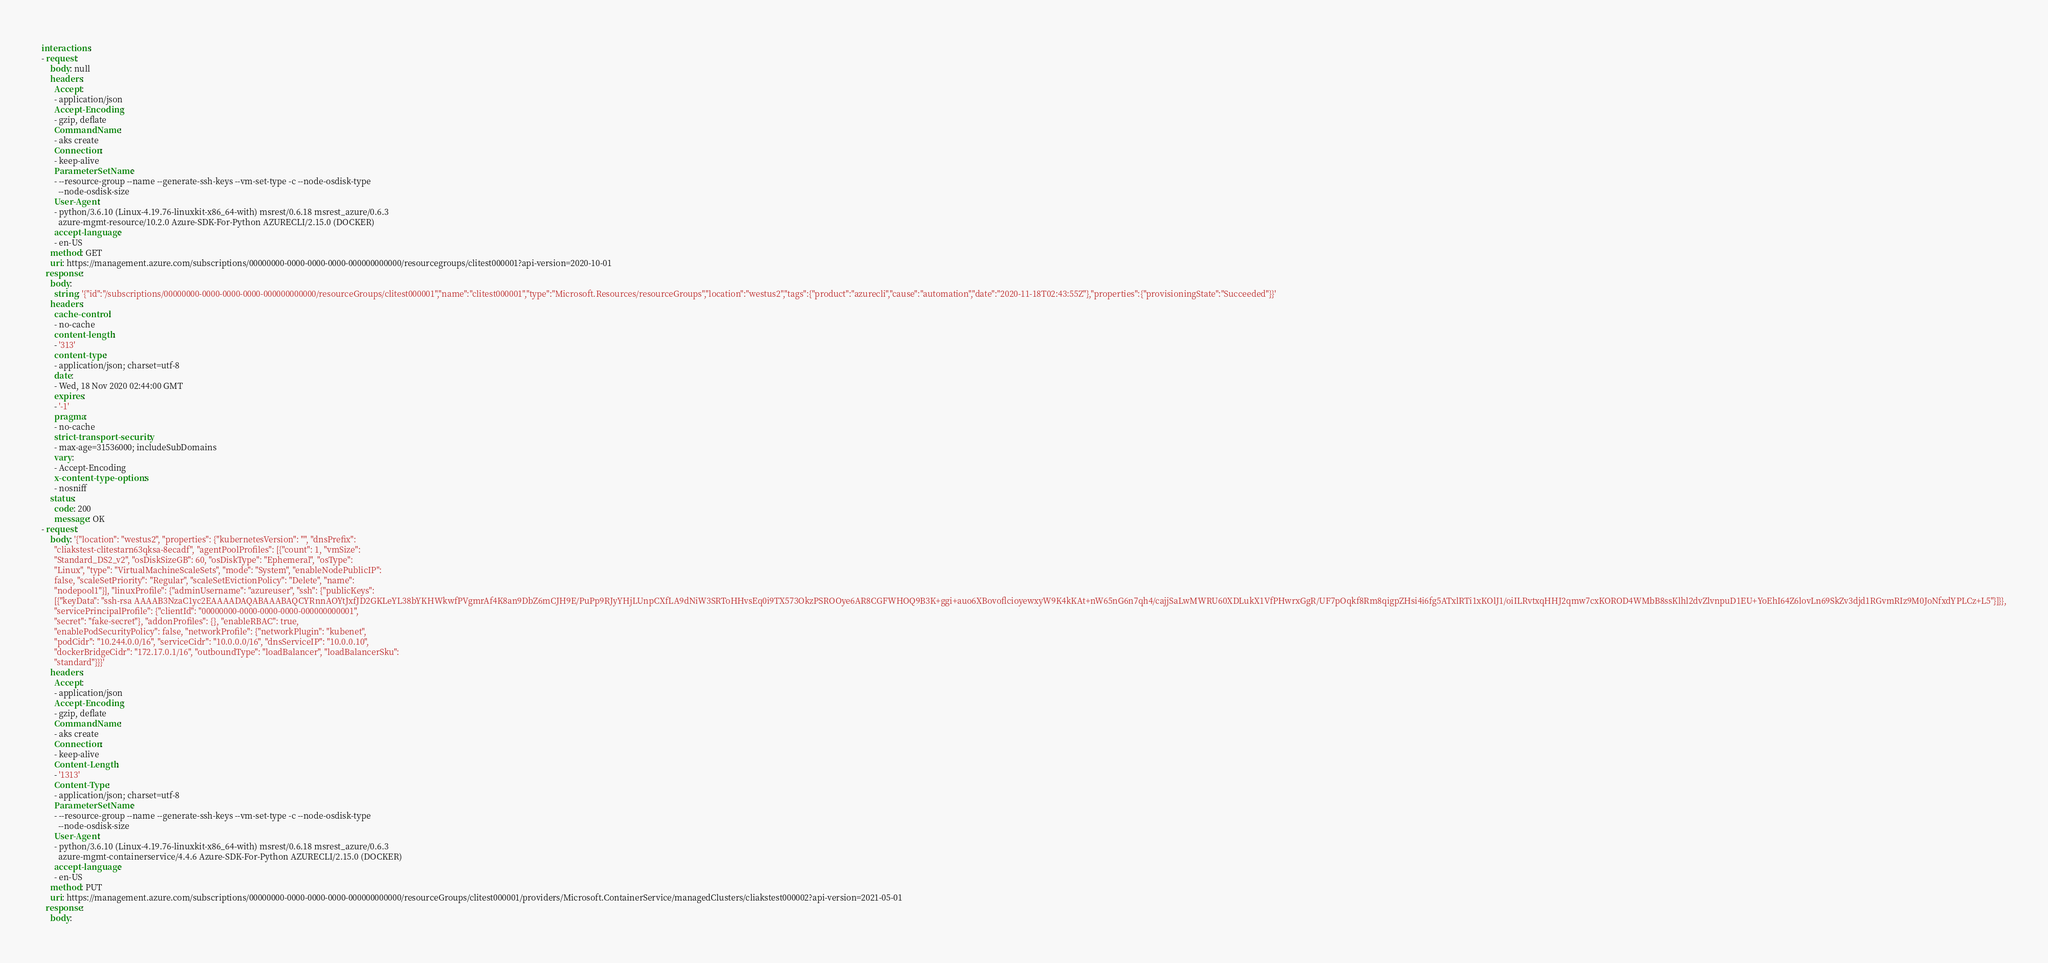Convert code to text. <code><loc_0><loc_0><loc_500><loc_500><_YAML_>interactions:
- request:
    body: null
    headers:
      Accept:
      - application/json
      Accept-Encoding:
      - gzip, deflate
      CommandName:
      - aks create
      Connection:
      - keep-alive
      ParameterSetName:
      - --resource-group --name --generate-ssh-keys --vm-set-type -c --node-osdisk-type
        --node-osdisk-size
      User-Agent:
      - python/3.6.10 (Linux-4.19.76-linuxkit-x86_64-with) msrest/0.6.18 msrest_azure/0.6.3
        azure-mgmt-resource/10.2.0 Azure-SDK-For-Python AZURECLI/2.15.0 (DOCKER)
      accept-language:
      - en-US
    method: GET
    uri: https://management.azure.com/subscriptions/00000000-0000-0000-0000-000000000000/resourcegroups/clitest000001?api-version=2020-10-01
  response:
    body:
      string: '{"id":"/subscriptions/00000000-0000-0000-0000-000000000000/resourceGroups/clitest000001","name":"clitest000001","type":"Microsoft.Resources/resourceGroups","location":"westus2","tags":{"product":"azurecli","cause":"automation","date":"2020-11-18T02:43:55Z"},"properties":{"provisioningState":"Succeeded"}}'
    headers:
      cache-control:
      - no-cache
      content-length:
      - '313'
      content-type:
      - application/json; charset=utf-8
      date:
      - Wed, 18 Nov 2020 02:44:00 GMT
      expires:
      - '-1'
      pragma:
      - no-cache
      strict-transport-security:
      - max-age=31536000; includeSubDomains
      vary:
      - Accept-Encoding
      x-content-type-options:
      - nosniff
    status:
      code: 200
      message: OK
- request:
    body: '{"location": "westus2", "properties": {"kubernetesVersion": "", "dnsPrefix":
      "cliakstest-clitestarn63qksa-8ecadf", "agentPoolProfiles": [{"count": 1, "vmSize":
      "Standard_DS2_v2", "osDiskSizeGB": 60, "osDiskType": "Ephemeral", "osType":
      "Linux", "type": "VirtualMachineScaleSets", "mode": "System", "enableNodePublicIP":
      false, "scaleSetPriority": "Regular", "scaleSetEvictionPolicy": "Delete", "name":
      "nodepool1"}], "linuxProfile": {"adminUsername": "azureuser", "ssh": {"publicKeys":
      [{"keyData": "ssh-rsa AAAAB3NzaC1yc2EAAAADAQABAAABAQCYRnnAOYtJxfJD2GKLeYL38bYKHWkwfPVgmrAf4K8an9DbZ6mCJH9E/PuPp9RJyYHjLUnpCXfLA9dNiW3SRToHHvsEq0i9TX573OkzPSROOye6AR8CGFWHOQ9B3K+ggi+auo6XBovoflcioyewxyW9K4kKAt+nW65nG6n7qh4/cajjSaLwMWRU60XDLukX1VfPHwrxGgR/UF7pOqkf8Rm8qigpZHsi4i6fg5ATxlRTi1xKOlJ1/oiILRvtxqHHJ2qmw7cxKOROD4WMbB8ssKlhl2dvZlvnpuD1EU+YoEhI64Z6lovLn69SkZv3djd1RGvmRIz9M0JoNfxdYPLCz+L5"}]}},
      "servicePrincipalProfile": {"clientId": "00000000-0000-0000-0000-000000000001",
      "secret": "fake-secret"}, "addonProfiles": {}, "enableRBAC": true,
      "enablePodSecurityPolicy": false, "networkProfile": {"networkPlugin": "kubenet",
      "podCidr": "10.244.0.0/16", "serviceCidr": "10.0.0.0/16", "dnsServiceIP": "10.0.0.10",
      "dockerBridgeCidr": "172.17.0.1/16", "outboundType": "loadBalancer", "loadBalancerSku":
      "standard"}}}'
    headers:
      Accept:
      - application/json
      Accept-Encoding:
      - gzip, deflate
      CommandName:
      - aks create
      Connection:
      - keep-alive
      Content-Length:
      - '1313'
      Content-Type:
      - application/json; charset=utf-8
      ParameterSetName:
      - --resource-group --name --generate-ssh-keys --vm-set-type -c --node-osdisk-type
        --node-osdisk-size
      User-Agent:
      - python/3.6.10 (Linux-4.19.76-linuxkit-x86_64-with) msrest/0.6.18 msrest_azure/0.6.3
        azure-mgmt-containerservice/4.4.6 Azure-SDK-For-Python AZURECLI/2.15.0 (DOCKER)
      accept-language:
      - en-US
    method: PUT
    uri: https://management.azure.com/subscriptions/00000000-0000-0000-0000-000000000000/resourceGroups/clitest000001/providers/Microsoft.ContainerService/managedClusters/cliakstest000002?api-version=2021-05-01
  response:
    body:</code> 